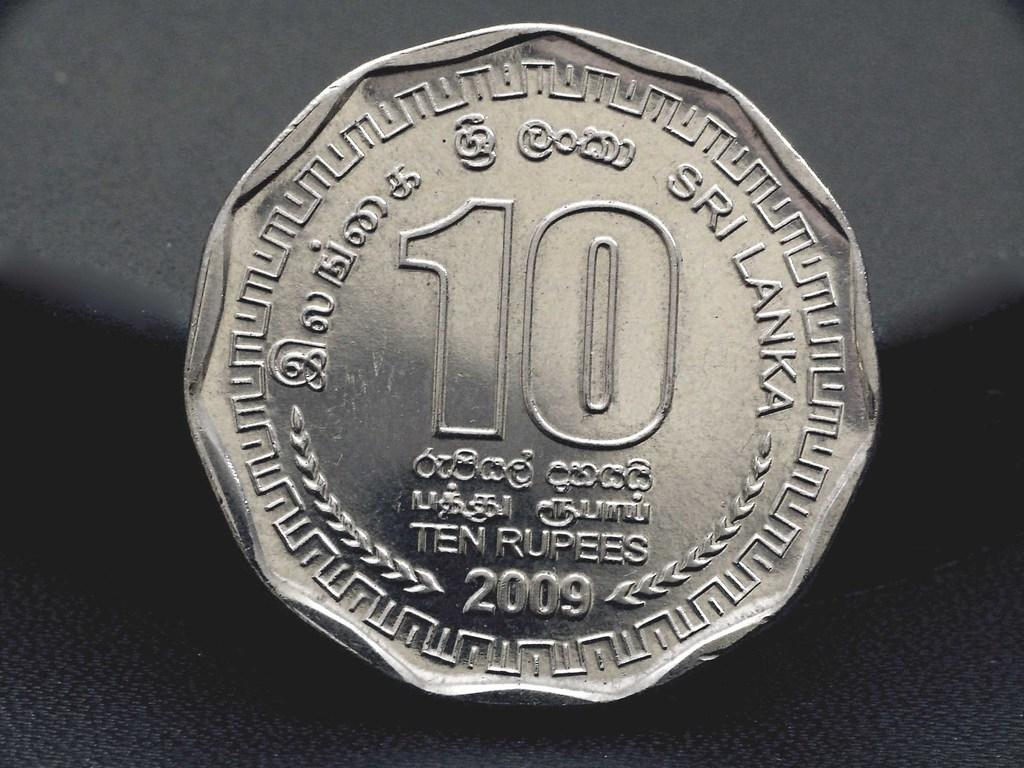What is the main subject of the image? The main subject of the image is a ten rupees coin. What color is the background of the image? The background of the image is black. What type of sound does the coin make when placed on the scale in the image? There is no scale or sound present in the image; it only features a ten rupees coin against a black background. 